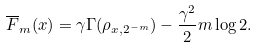Convert formula to latex. <formula><loc_0><loc_0><loc_500><loc_500>\overline { F } _ { m } ( x ) = \gamma \Gamma ( \rho _ { x , 2 ^ { - m } } ) - \frac { \gamma ^ { 2 } } { 2 } m \log 2 .</formula> 